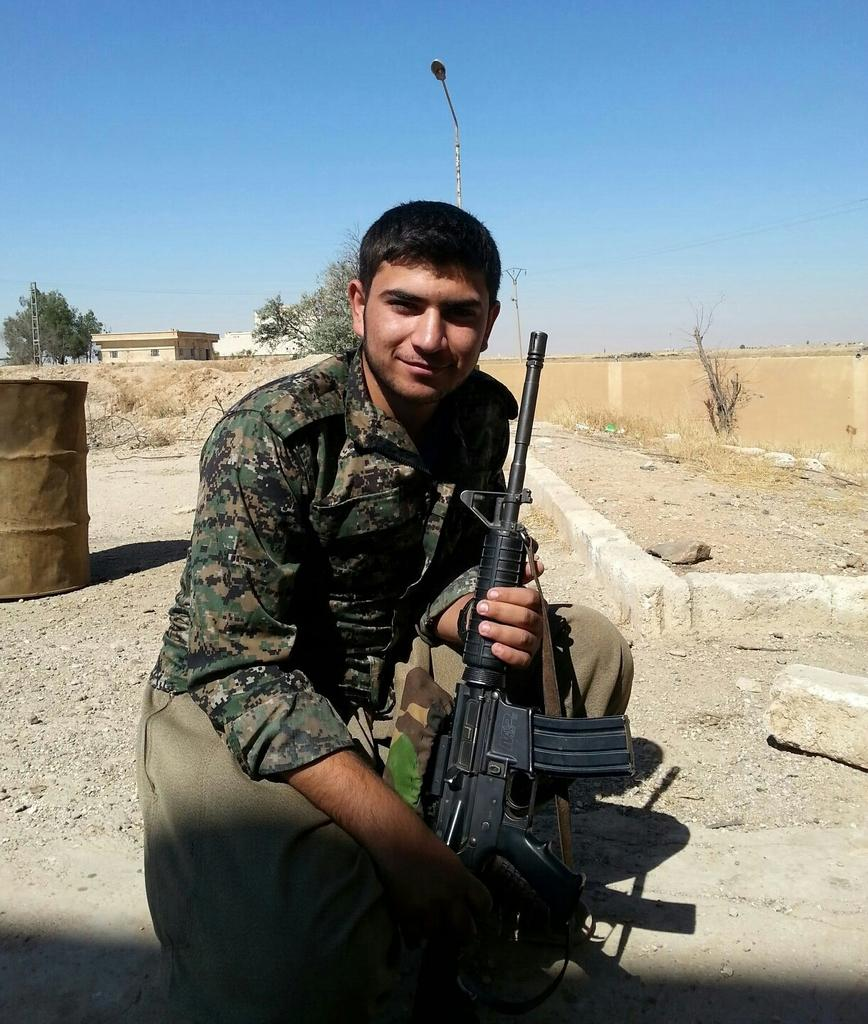Who is the main subject in the image? There is a man in the center of the image. What is the man doing in the image? The man is smiling and holding a gun. What can be seen in the background of the image? There is a barrel, trees, a home, and a pole in the background of the image. What type of print can be seen on the zebra in the image? There is no zebra present in the image, so there is no print to observe. How many tickets are visible in the image? There are no tickets visible in the image. 